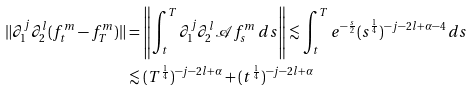Convert formula to latex. <formula><loc_0><loc_0><loc_500><loc_500>\| \partial _ { 1 } ^ { j } \partial _ { 2 } ^ { l } ( f ^ { m } _ { t } - f ^ { m } _ { T } ) \| & = \left \| \int ^ { T } _ { t } \partial _ { 1 } ^ { j } \partial _ { 2 } ^ { l } \mathcal { A } f ^ { m } _ { s } \, d s \right \| \lesssim \int ^ { T } _ { t } e ^ { - \frac { s } { 2 } } ( s ^ { \frac { 1 } { 4 } } ) ^ { - j - 2 l + \alpha - 4 } \, d s \\ & \lesssim ( T ^ { \frac { 1 } { 4 } } ) ^ { - j - 2 l + \alpha } + ( t ^ { \frac { 1 } { 4 } } ) ^ { - j - 2 l + \alpha }</formula> 